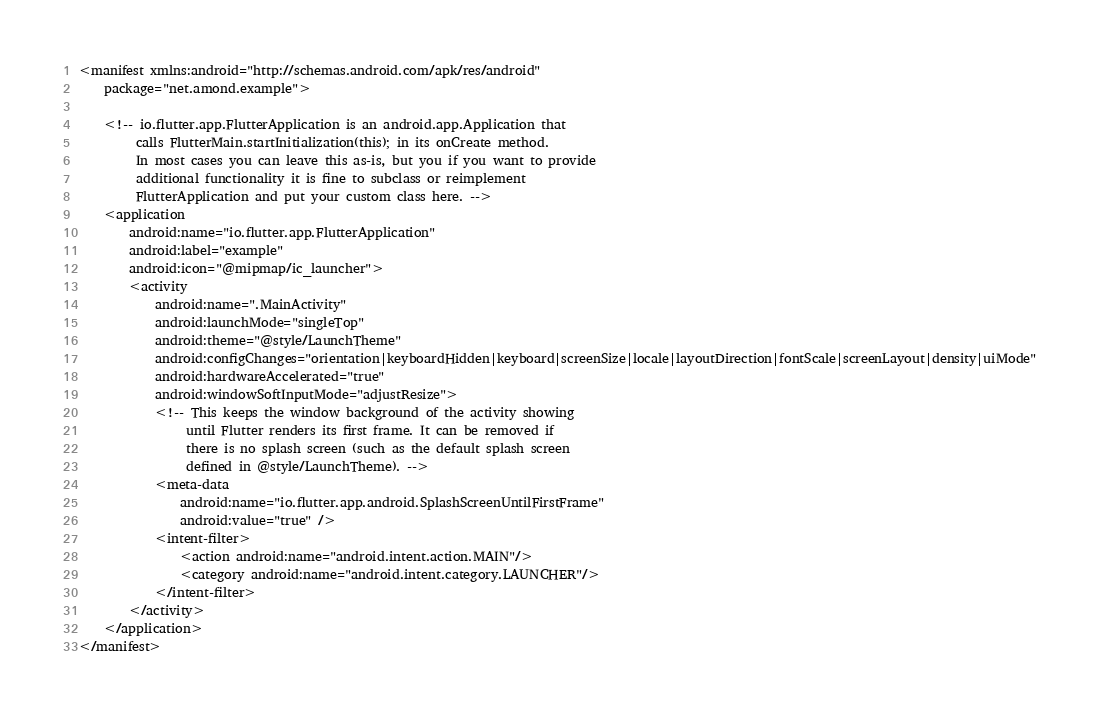Convert code to text. <code><loc_0><loc_0><loc_500><loc_500><_XML_><manifest xmlns:android="http://schemas.android.com/apk/res/android"
    package="net.amond.example">

    <!-- io.flutter.app.FlutterApplication is an android.app.Application that
         calls FlutterMain.startInitialization(this); in its onCreate method.
         In most cases you can leave this as-is, but you if you want to provide
         additional functionality it is fine to subclass or reimplement
         FlutterApplication and put your custom class here. -->
    <application
        android:name="io.flutter.app.FlutterApplication"
        android:label="example"
        android:icon="@mipmap/ic_launcher">
        <activity
            android:name=".MainActivity"
            android:launchMode="singleTop"
            android:theme="@style/LaunchTheme"
            android:configChanges="orientation|keyboardHidden|keyboard|screenSize|locale|layoutDirection|fontScale|screenLayout|density|uiMode"
            android:hardwareAccelerated="true"
            android:windowSoftInputMode="adjustResize">
            <!-- This keeps the window background of the activity showing
                 until Flutter renders its first frame. It can be removed if
                 there is no splash screen (such as the default splash screen
                 defined in @style/LaunchTheme). -->
            <meta-data
                android:name="io.flutter.app.android.SplashScreenUntilFirstFrame"
                android:value="true" />
            <intent-filter>
                <action android:name="android.intent.action.MAIN"/>
                <category android:name="android.intent.category.LAUNCHER"/>
            </intent-filter>
        </activity>
    </application>
</manifest>
</code> 